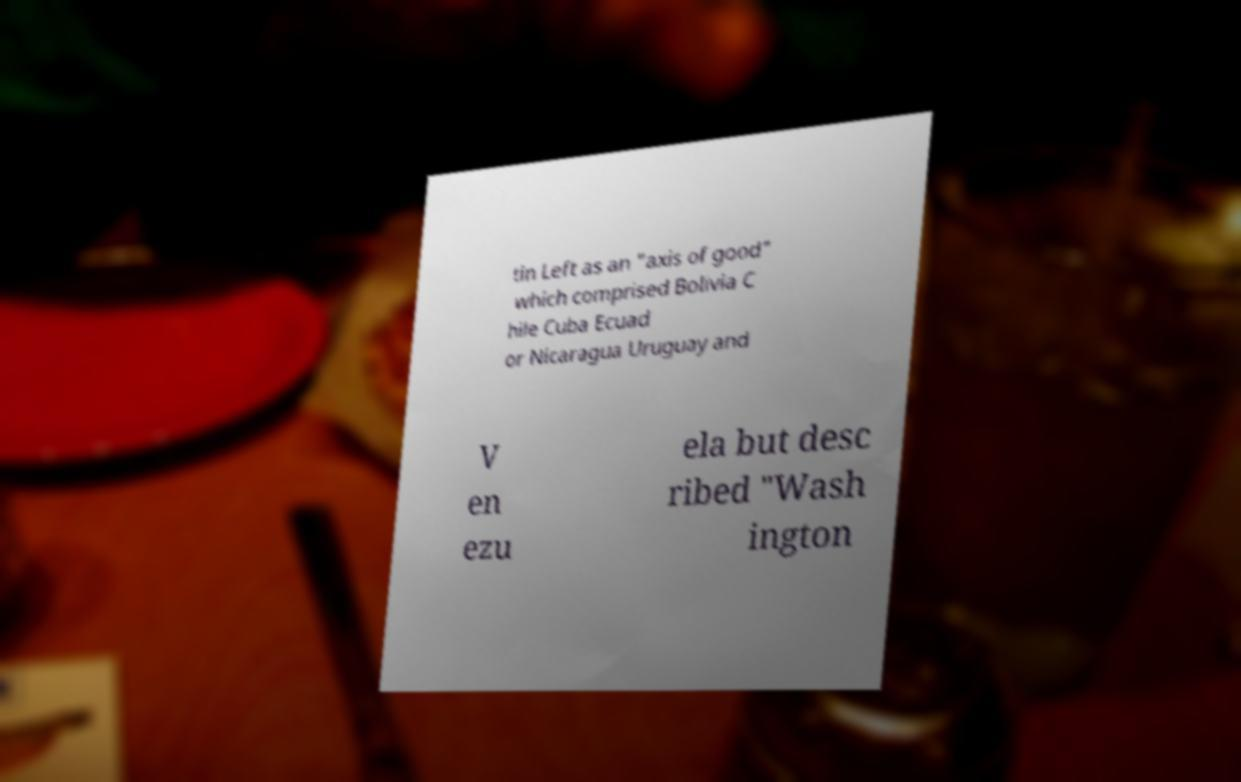Can you accurately transcribe the text from the provided image for me? tin Left as an "axis of good" which comprised Bolivia C hile Cuba Ecuad or Nicaragua Uruguay and V en ezu ela but desc ribed "Wash ington 